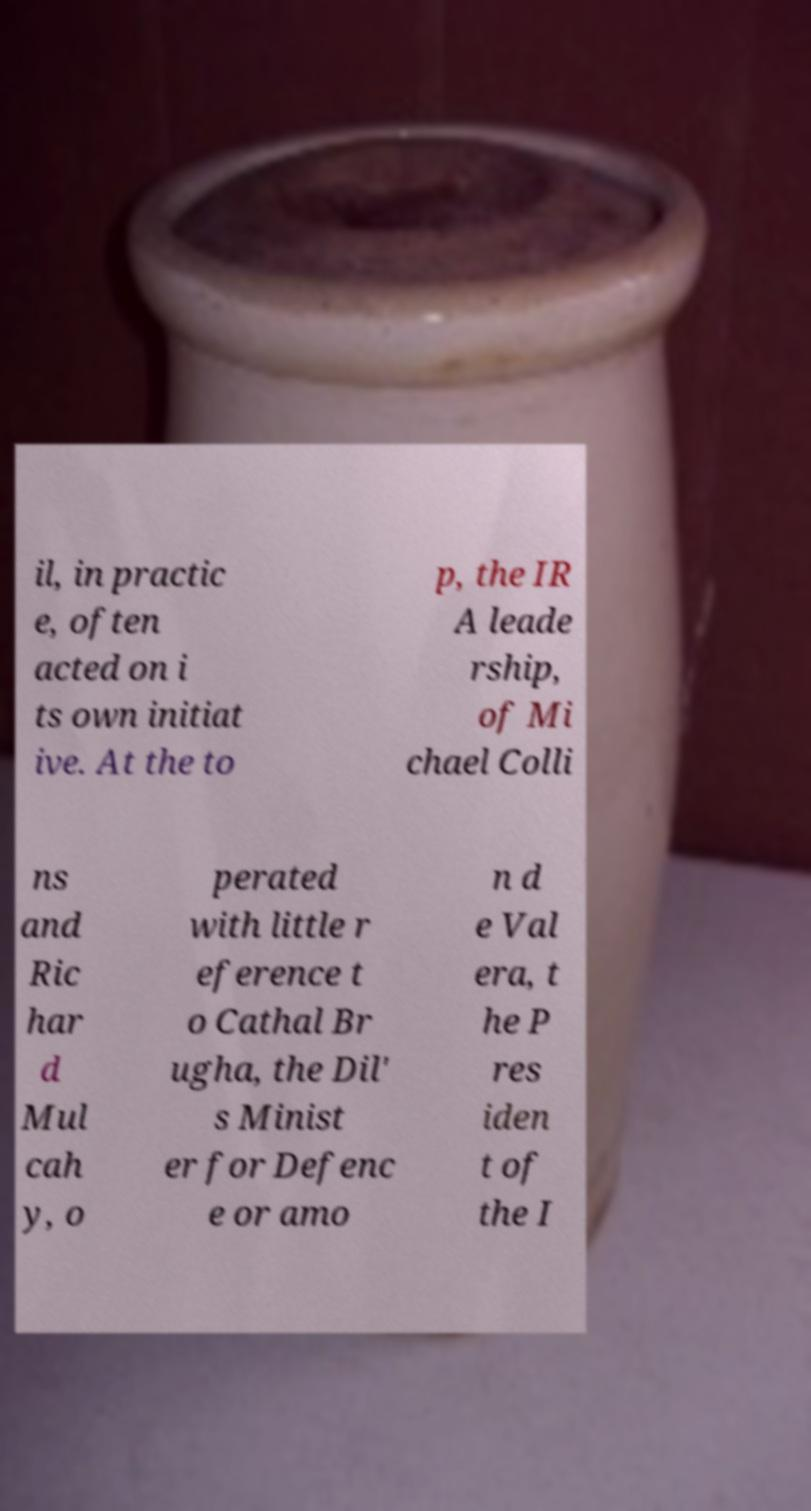I need the written content from this picture converted into text. Can you do that? il, in practic e, often acted on i ts own initiat ive. At the to p, the IR A leade rship, of Mi chael Colli ns and Ric har d Mul cah y, o perated with little r eference t o Cathal Br ugha, the Dil' s Minist er for Defenc e or amo n d e Val era, t he P res iden t of the I 